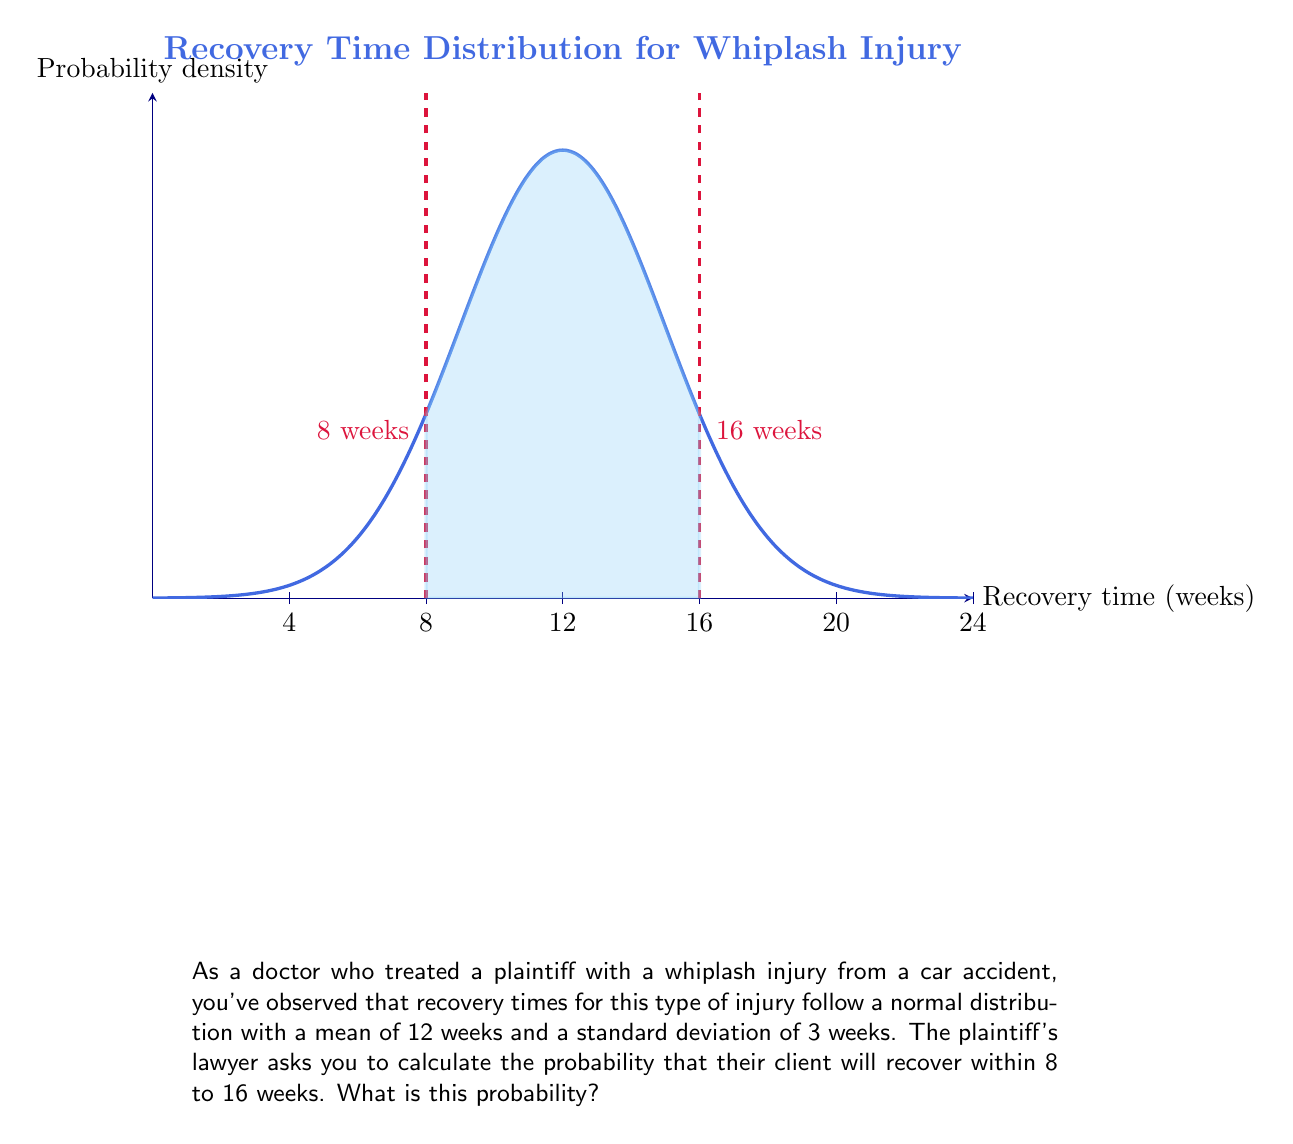What is the answer to this math problem? To solve this problem, we need to use the properties of the normal distribution and the concept of z-scores. Let's follow these steps:

1) First, we need to calculate the z-scores for both 8 weeks and 16 weeks.
   The z-score formula is: $z = \frac{x - \mu}{\sigma}$

   Where $x$ is the value, $\mu$ is the mean, and $\sigma$ is the standard deviation.

2) For 8 weeks:
   $z_1 = \frac{8 - 12}{3} = -\frac{4}{3} \approx -1.33$

3) For 16 weeks:
   $z_2 = \frac{16 - 12}{3} = \frac{4}{3} \approx 1.33$

4) Now, we need to find the area under the standard normal curve between these two z-scores.
   This is equivalent to finding $P(-1.33 < Z < 1.33)$

5) We can calculate this using the standard normal distribution table or a calculator:
   $P(-1.33 < Z < 1.33) = P(Z < 1.33) - P(Z < -1.33)$
                        $= 0.9082 - 0.0918$
                        $= 0.8164$

6) Therefore, the probability that the plaintiff will recover within 8 to 16 weeks is approximately 0.8164 or 81.64%.
Answer: $0.8164$ or $81.64\%$ 